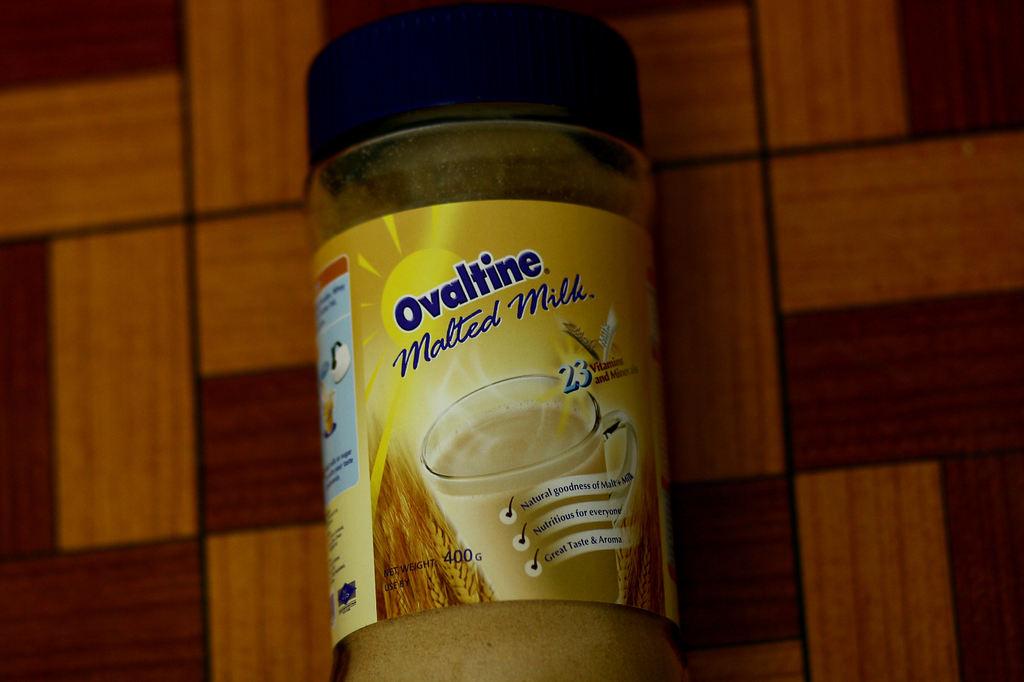What type of milk is it?
Ensure brevity in your answer.  Malted. What is the name of this brand?
Your answer should be very brief. Ovaltine. 